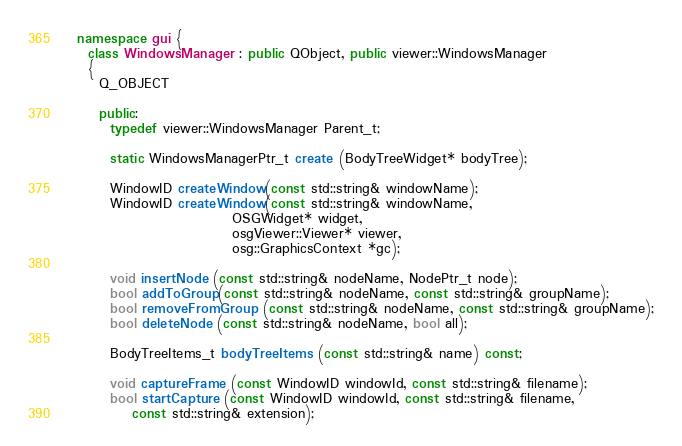<code> <loc_0><loc_0><loc_500><loc_500><_C++_>  namespace gui {
    class WindowsManager : public QObject, public viewer::WindowsManager
    {
      Q_OBJECT

      public:
        typedef viewer::WindowsManager Parent_t;

        static WindowsManagerPtr_t create (BodyTreeWidget* bodyTree);

        WindowID createWindow(const std::string& windowName);
        WindowID createWindow(const std::string& windowName,
                              OSGWidget* widget,
                              osgViewer::Viewer* viewer,
                              osg::GraphicsContext *gc);

        void insertNode (const std::string& nodeName, NodePtr_t node);
        bool addToGroup(const std::string& nodeName, const std::string& groupName);
        bool removeFromGroup (const std::string& nodeName, const std::string& groupName);
        bool deleteNode (const std::string& nodeName, bool all);

        BodyTreeItems_t bodyTreeItems (const std::string& name) const;

        void captureFrame (const WindowID windowId, const std::string& filename);
        bool startCapture (const WindowID windowId, const std::string& filename,
            const std::string& extension);</code> 